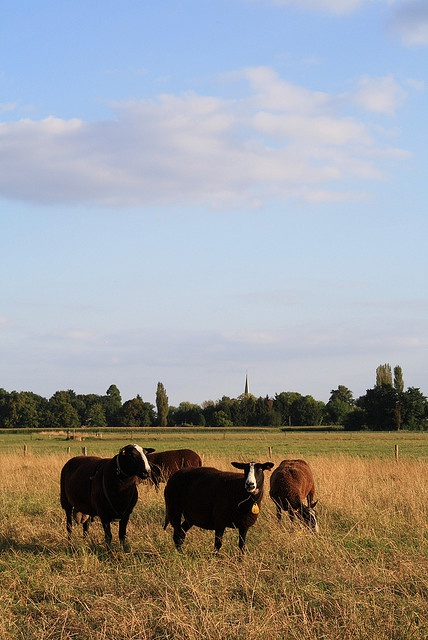Describe the objects in this image and their specific colors. I can see cow in lightblue, black, olive, and maroon tones, cow in lightblue, black, maroon, and olive tones, sheep in lightblue, black, maroon, and brown tones, sheep in lightblue, black, maroon, and olive tones, and cow in lightblue, black, maroon, and brown tones in this image. 